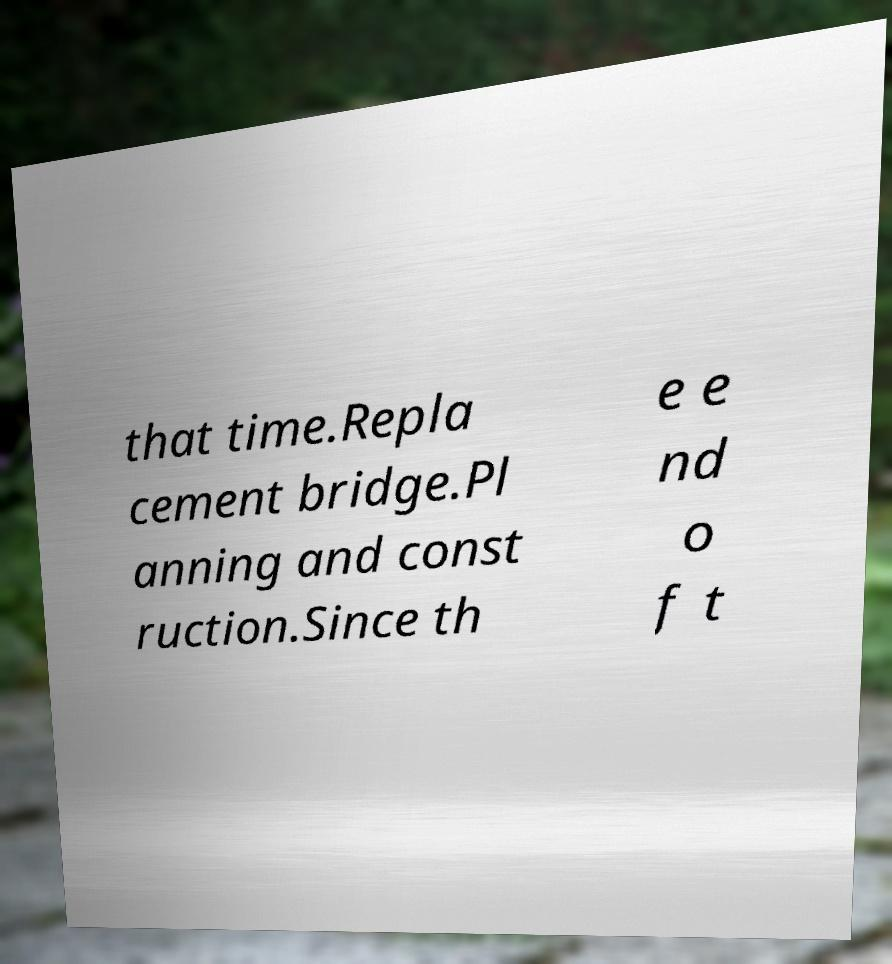What messages or text are displayed in this image? I need them in a readable, typed format. that time.Repla cement bridge.Pl anning and const ruction.Since th e e nd o f t 